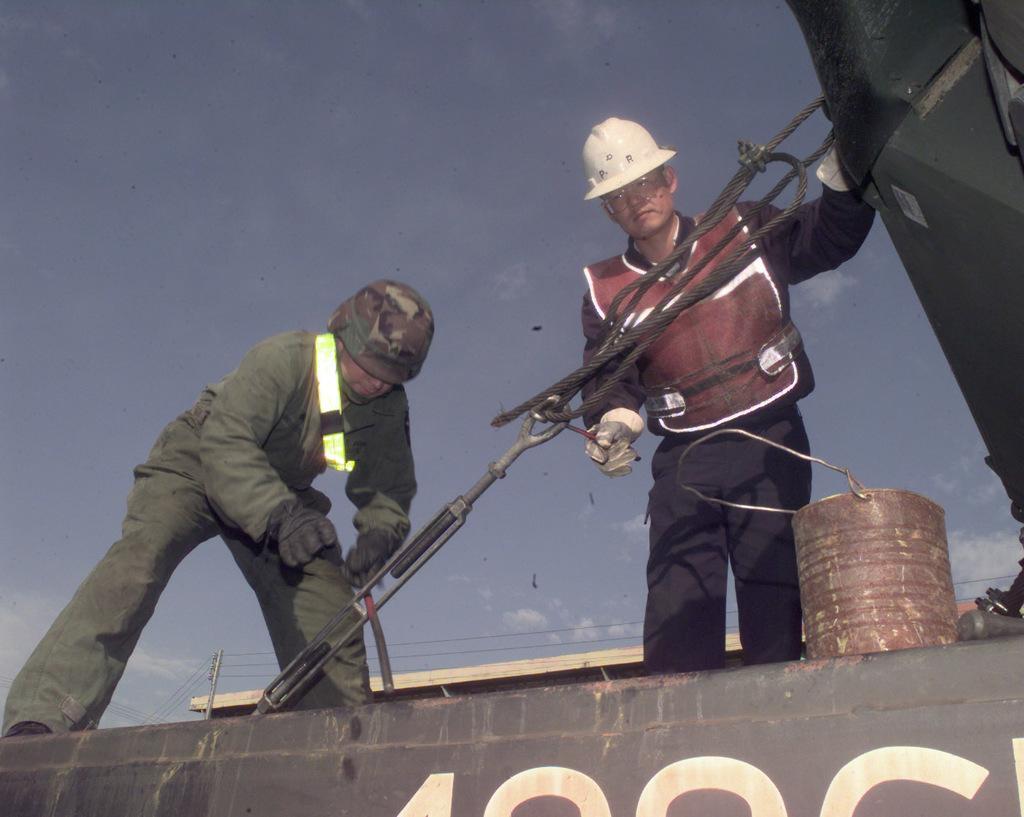Describe this image in one or two sentences. In this image we can see two persons are standing on a platform and holding objects in their hands. We can see objects, ropes and a bucket. In the background we can see a pole, wires, an object and clouds in the sky. 